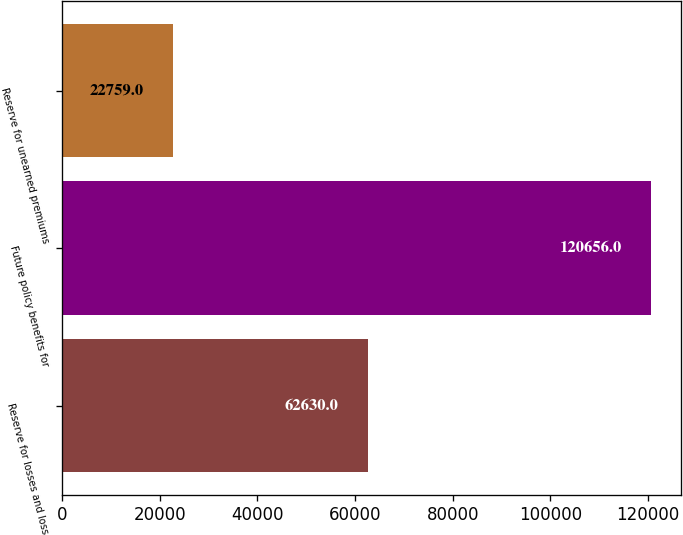Convert chart to OTSL. <chart><loc_0><loc_0><loc_500><loc_500><bar_chart><fcel>Reserve for losses and loss<fcel>Future policy benefits for<fcel>Reserve for unearned premiums<nl><fcel>62630<fcel>120656<fcel>22759<nl></chart> 